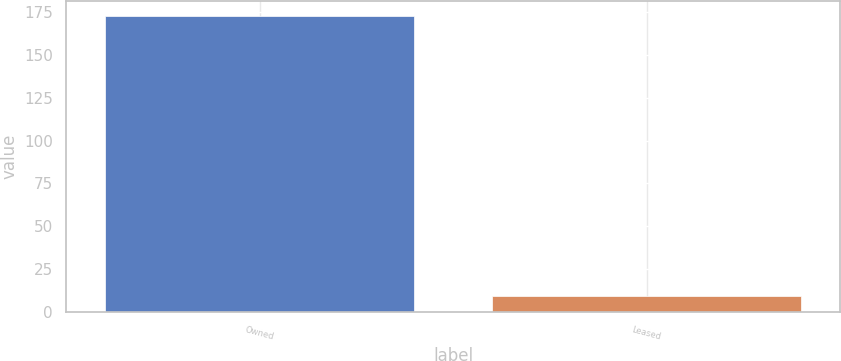<chart> <loc_0><loc_0><loc_500><loc_500><bar_chart><fcel>Owned<fcel>Leased<nl><fcel>173<fcel>9<nl></chart> 